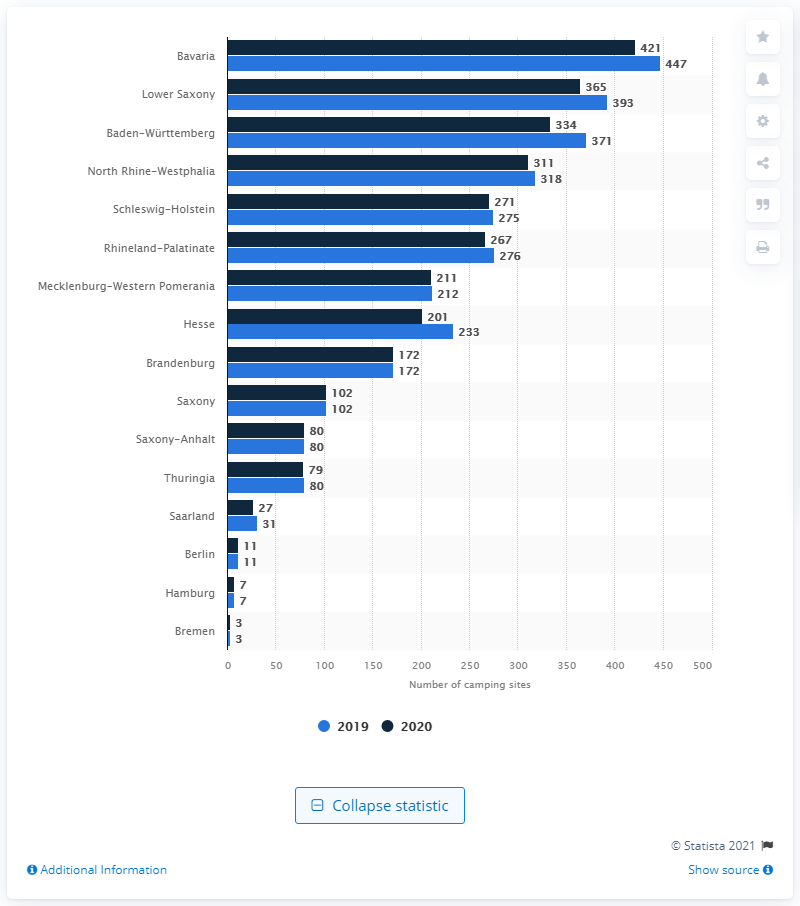Which state had the highest number of camping sites in Germany in 2020? In 2020, Bavaria boasted the highest number of camping sites among all German states, with a total of 447 sites, making it a prime destination for campers seeking a variety of landscapes and experiences. 